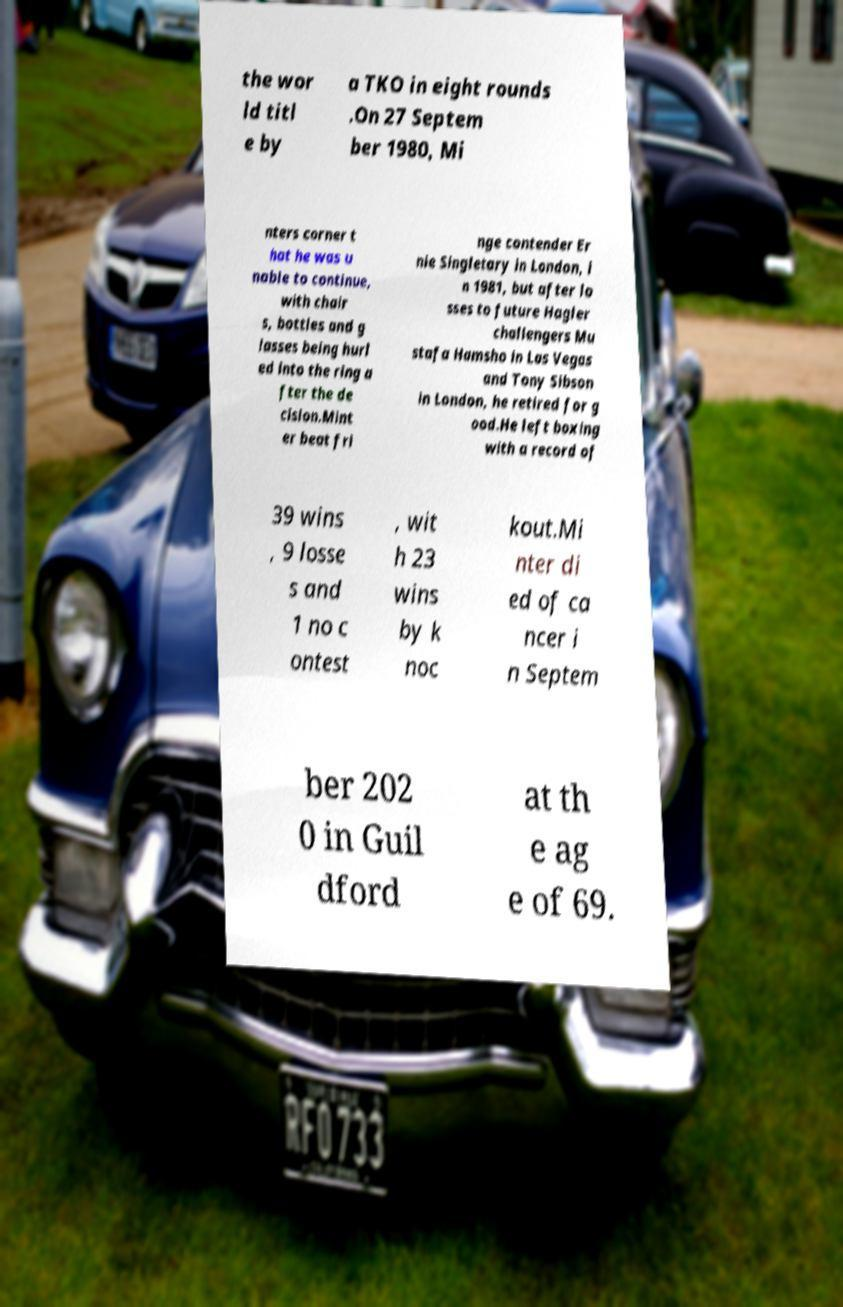There's text embedded in this image that I need extracted. Can you transcribe it verbatim? the wor ld titl e by a TKO in eight rounds .On 27 Septem ber 1980, Mi nters corner t hat he was u nable to continue, with chair s, bottles and g lasses being hurl ed into the ring a fter the de cision.Mint er beat fri nge contender Er nie Singletary in London, i n 1981, but after lo sses to future Hagler challengers Mu stafa Hamsho in Las Vegas and Tony Sibson in London, he retired for g ood.He left boxing with a record of 39 wins , 9 losse s and 1 no c ontest , wit h 23 wins by k noc kout.Mi nter di ed of ca ncer i n Septem ber 202 0 in Guil dford at th e ag e of 69. 